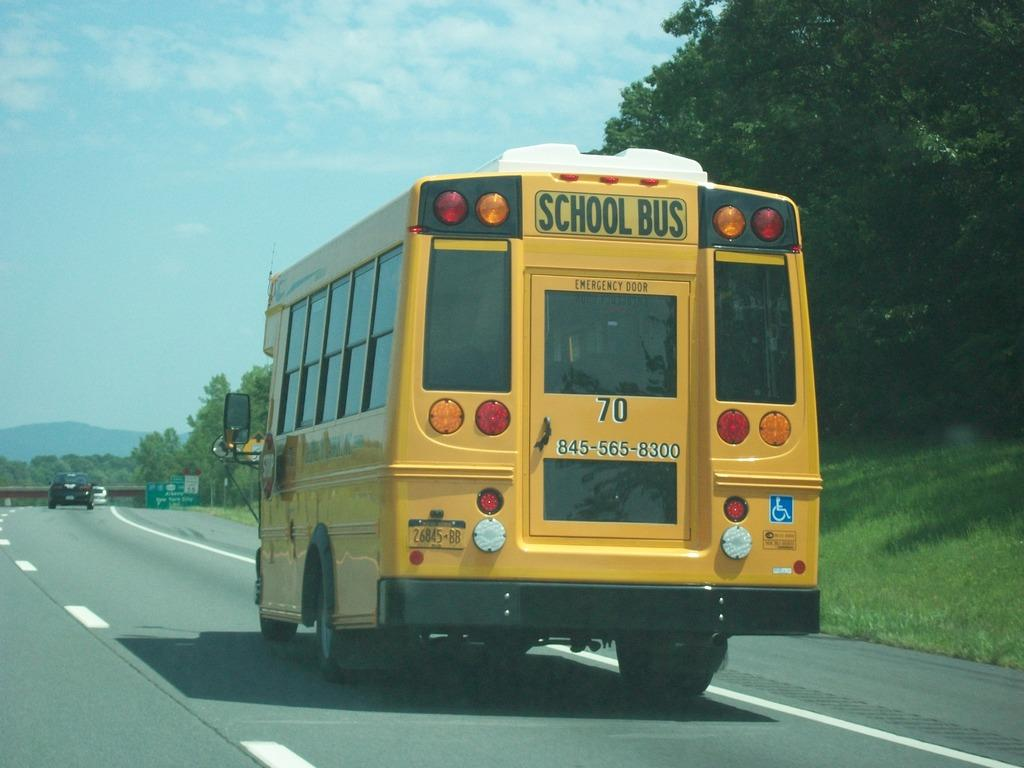What type of vehicle is in the image? There is a yellow school bus in the image. What is happening with the other vehicles in the image? Other vehicles are moving on the road in the image. What type of vegetation can be seen in the image? Grass and trees are visible in the image. What structures are present in the image? Boards and a bridge are present in the image. What can be seen in the background of the image? Hills and the sky are visible in the background of the image. How many snails are crawling on the school bus in the image? There are no snails visible on the school bus in the image. What is the school bus doing with its hands in the image? School buses do not have hands, as they are inanimate objects. 